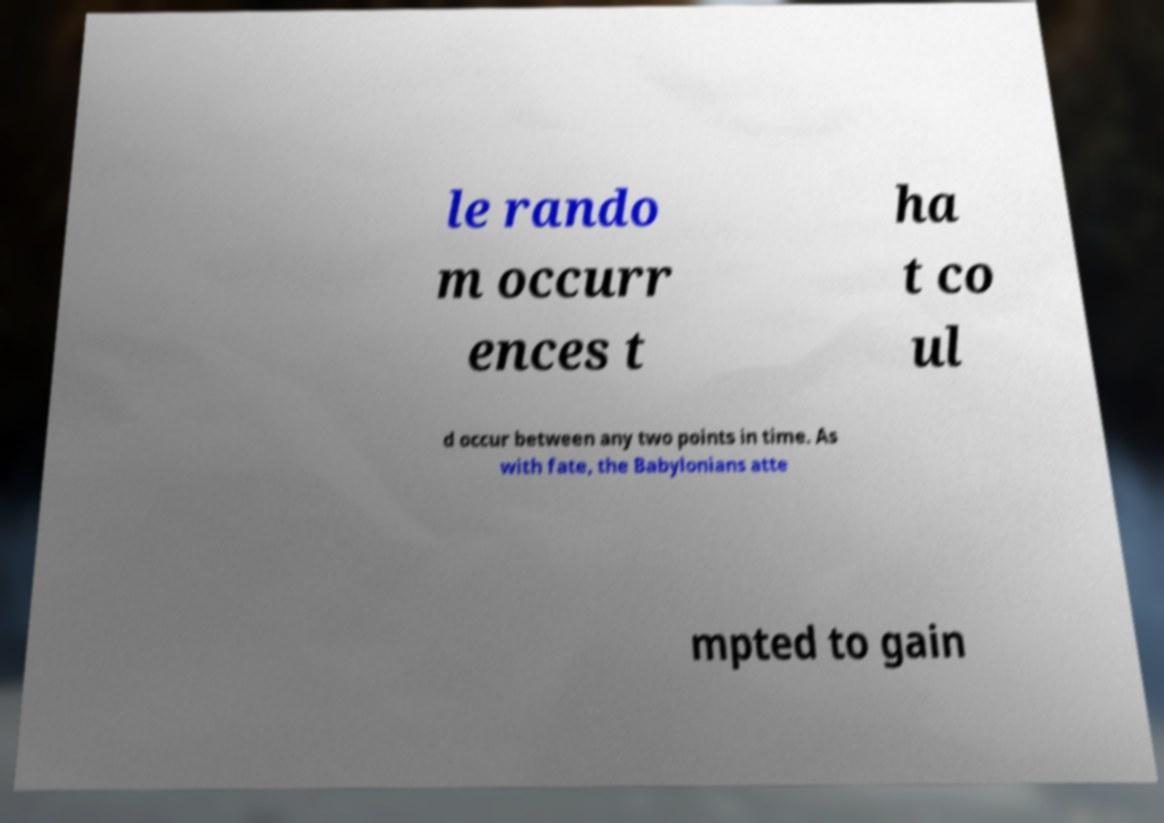Please identify and transcribe the text found in this image. le rando m occurr ences t ha t co ul d occur between any two points in time. As with fate, the Babylonians atte mpted to gain 